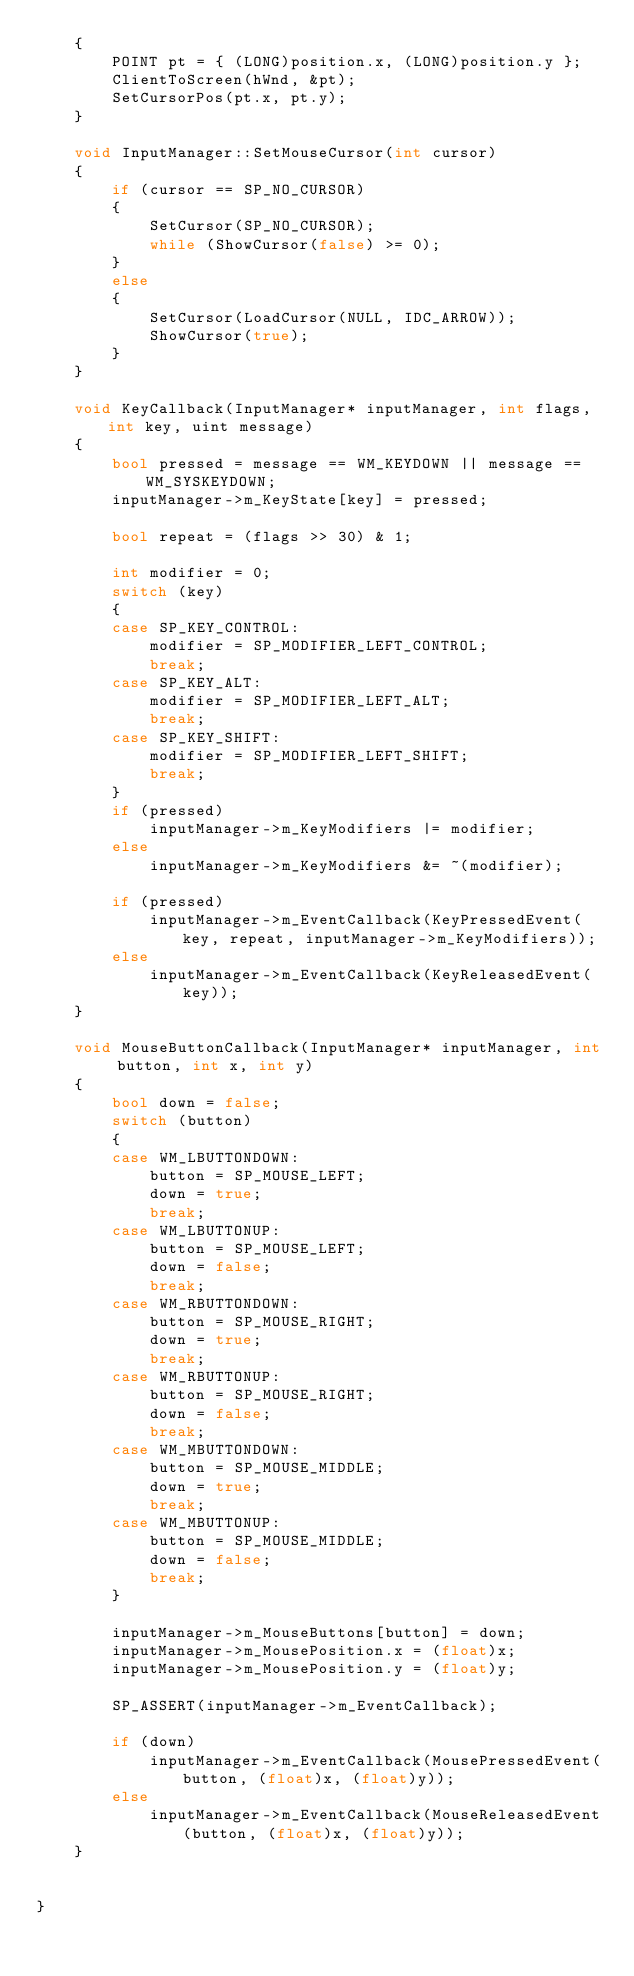Convert code to text. <code><loc_0><loc_0><loc_500><loc_500><_C++_>	{
		POINT pt = { (LONG)position.x, (LONG)position.y };
		ClientToScreen(hWnd, &pt);
		SetCursorPos(pt.x, pt.y);
	}

	void InputManager::SetMouseCursor(int cursor)
	{
		if (cursor == SP_NO_CURSOR)
		{
			SetCursor(SP_NO_CURSOR);
			while (ShowCursor(false) >= 0);
		}
		else
		{
			SetCursor(LoadCursor(NULL, IDC_ARROW));
			ShowCursor(true);
		}
	}

	void KeyCallback(InputManager* inputManager, int flags, int key, uint message)
	{
		bool pressed = message == WM_KEYDOWN || message == WM_SYSKEYDOWN;
		inputManager->m_KeyState[key] = pressed;

		bool repeat = (flags >> 30) & 1;

		int modifier = 0;
		switch (key)
		{
		case SP_KEY_CONTROL:
			modifier = SP_MODIFIER_LEFT_CONTROL;
			break;
		case SP_KEY_ALT:
			modifier = SP_MODIFIER_LEFT_ALT;
			break;
		case SP_KEY_SHIFT:
			modifier = SP_MODIFIER_LEFT_SHIFT;
			break;
		}
		if (pressed)
			inputManager->m_KeyModifiers |= modifier;
		else
			inputManager->m_KeyModifiers &= ~(modifier);

		if (pressed)
			inputManager->m_EventCallback(KeyPressedEvent(key, repeat, inputManager->m_KeyModifiers));
		else
			inputManager->m_EventCallback(KeyReleasedEvent(key));
	}

	void MouseButtonCallback(InputManager* inputManager, int button, int x, int y)
	{
		bool down = false;
		switch (button)
		{
		case WM_LBUTTONDOWN:
			button = SP_MOUSE_LEFT;
			down = true;
			break;
		case WM_LBUTTONUP:
			button = SP_MOUSE_LEFT;
			down = false;
			break;
		case WM_RBUTTONDOWN:
			button = SP_MOUSE_RIGHT;
			down = true;
			break;
		case WM_RBUTTONUP:
			button = SP_MOUSE_RIGHT;
			down = false;
			break;
		case WM_MBUTTONDOWN:
			button = SP_MOUSE_MIDDLE;
			down = true;
			break;
		case WM_MBUTTONUP:
			button = SP_MOUSE_MIDDLE;
			down = false;
			break;
		}

		inputManager->m_MouseButtons[button] = down;
		inputManager->m_MousePosition.x = (float)x;
		inputManager->m_MousePosition.y = (float)y;

		SP_ASSERT(inputManager->m_EventCallback);

		if (down)
			inputManager->m_EventCallback(MousePressedEvent(button, (float)x, (float)y));
		else
			inputManager->m_EventCallback(MouseReleasedEvent(button, (float)x, (float)y));
	}


}</code> 